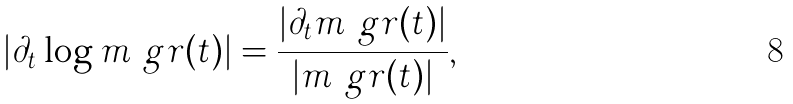<formula> <loc_0><loc_0><loc_500><loc_500>| \partial _ { t } \log m _ { \ } g r ( t ) | = \frac { | \partial _ { t } m _ { \ } g r ( t ) | } { | m _ { \ } g r ( t ) | } ,</formula> 